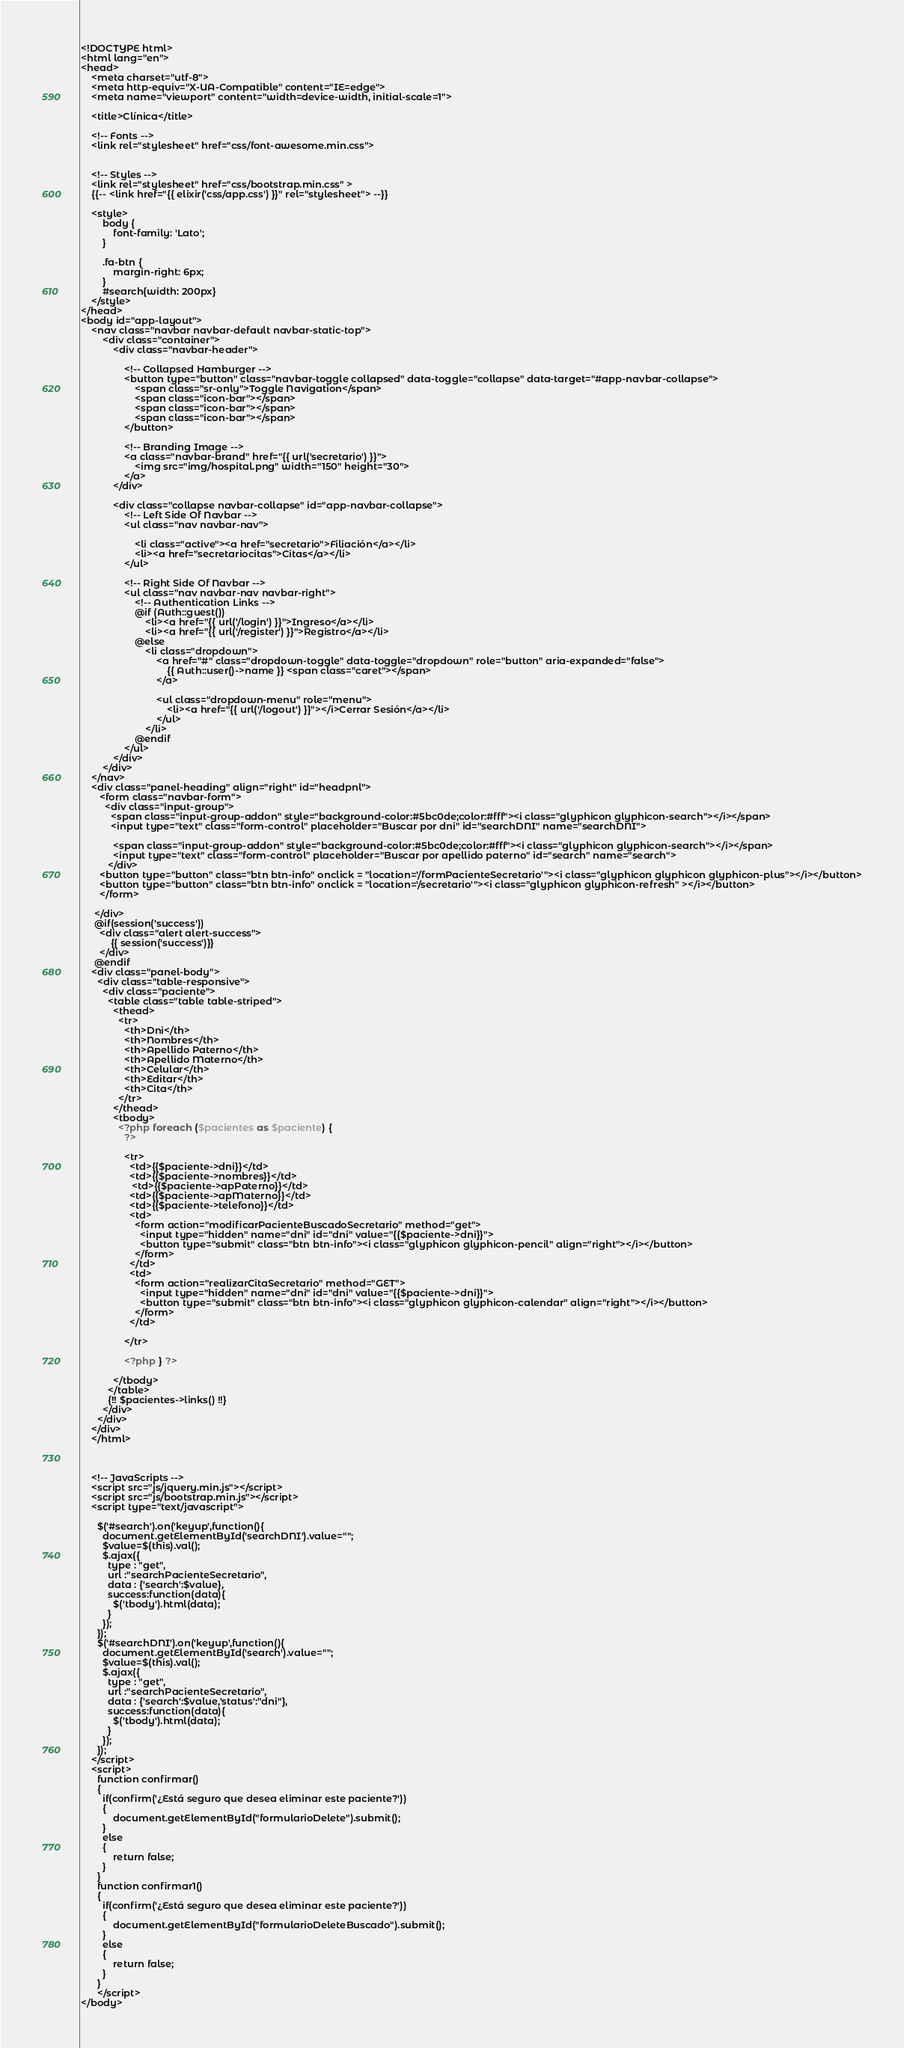<code> <loc_0><loc_0><loc_500><loc_500><_PHP_><!DOCTYPE html>
<html lang="en">
<head>
    <meta charset="utf-8">
    <meta http-equiv="X-UA-Compatible" content="IE=edge">
    <meta name="viewport" content="width=device-width, initial-scale=1">

    <title>Clínica</title>

    <!-- Fonts -->
    <link rel="stylesheet" href="css/font-awesome.min.css">


    <!-- Styles -->
    <link rel="stylesheet" href="css/bootstrap.min.css" >
    {{-- <link href="{{ elixir('css/app.css') }}" rel="stylesheet"> --}}

    <style>
        body {
            font-family: 'Lato';
        }

        .fa-btn {
            margin-right: 6px;
        }
        #search{width: 200px}
    </style>
</head>
<body id="app-layout">
    <nav class="navbar navbar-default navbar-static-top">
        <div class="container">
            <div class="navbar-header">

                <!-- Collapsed Hamburger -->
                <button type="button" class="navbar-toggle collapsed" data-toggle="collapse" data-target="#app-navbar-collapse">
                    <span class="sr-only">Toggle Navigation</span>
                    <span class="icon-bar"></span>
                    <span class="icon-bar"></span>
                    <span class="icon-bar"></span>
                </button>

                <!-- Branding Image -->
                <a class="navbar-brand" href="{{ url('secretario') }}">
                    <img src="img/hospital.png" width="150" height="30">
                </a>
            </div>

            <div class="collapse navbar-collapse" id="app-navbar-collapse">
                <!-- Left Side Of Navbar -->
                <ul class="nav navbar-nav">

                    <li class="active"><a href="secretario">Filiación</a></li>
                    <li><a href="secretariocitas">Citas</a></li>
                </ul>

                <!-- Right Side Of Navbar -->
                <ul class="nav navbar-nav navbar-right">
                    <!-- Authentication Links -->
                    @if (Auth::guest())
                        <li><a href="{{ url('/login') }}">Ingreso</a></li>
                        <li><a href="{{ url('/register') }}">Registro</a></li>
                    @else
                        <li class="dropdown">
                            <a href="#" class="dropdown-toggle" data-toggle="dropdown" role="button" aria-expanded="false">
                                {{ Auth::user()->name }} <span class="caret"></span>
                            </a>

                            <ul class="dropdown-menu" role="menu">
                                <li><a href="{{ url('/logout') }}"></i>Cerrar Sesión</a></li>
                            </ul>
                        </li>
                    @endif
                </ul>
            </div>
        </div>
    </nav>
    <div class="panel-heading" align="right" id="headpnl">
       <form class="navbar-form">
         <div class="input-group">
           <span class="input-group-addon" style="background-color:#5bc0de;color:#fff"><i class="glyphicon glyphicon-search"></i></span>
           <input type="text" class="form-control" placeholder="Buscar por dni" id="searchDNI" name="searchDNI">

            <span class="input-group-addon" style="background-color:#5bc0de;color:#fff"><i class="glyphicon glyphicon-search"></i></span>
            <input type="text" class="form-control" placeholder="Buscar por apellido paterno" id="search" name="search">
          </div>
       <button type="button" class="btn btn-info" onclick = "location='/formPacienteSecretario'"><i class="glyphicon glyphicon glyphicon-plus"></i></button>
       <button type="button" class="btn btn-info" onclick = "location='/secretario'"><i class="glyphicon glyphicon-refresh" ></i></button>
       </form>

     </div>
     @if(session('success'))
       <div class="alert alert-success">
           {{ session('success')}}
       </div>
     @endif
    <div class="panel-body">
      <div class="table-responsive">
        <div class="paciente">
          <table class="table table-striped">
            <thead>
              <tr>
                <th>Dni</th>
                <th>Nombres</th>
                <th>Apellido Paterno</th>
                <th>Apellido Materno</th>
                <th>Celular</th>
                <th>Editar</th>
                <th>Cita</th>
              </tr>
            </thead>
            <tbody>
              <?php foreach ($pacientes as $paciente) {
                ?>

                <tr>
                  <td>{{$paciente->dni}}</td>
                  <td>{{$paciente->nombres}}</td>
                   <td>{{$paciente->apPaterno}}</td>
                  <td>{{$paciente->apMaterno}}</td>
                  <td>{{$paciente->telefono}}</td>
                  <td>
                    <form action="modificarPacienteBuscadoSecretario" method="get">
                      <input type="hidden" name="dni" id="dni" value="{{$paciente->dni}}">
                      <button type="submit" class="btn btn-info"><i class="glyphicon glyphicon-pencil" align="right"></i></button>
                    </form>
                  </td>
                  <td>
                    <form action="realizarCitaSecretario" method="GET">
                      <input type="hidden" name="dni" id="dni" value="{{$paciente->dni}}">
                      <button type="submit" class="btn btn-info"><i class="glyphicon glyphicon-calendar" align="right"></i></button>
                    </form>
                  </td>

                </tr>

                <?php } ?>

            </tbody>
          </table>
          {!! $pacientes->links() !!}
        </div>
      </div>
    </div>
    </html>



    <!-- JavaScripts -->
    <script src="js/jquery.min.js"></script>
    <script src="js/bootstrap.min.js"></script>
    <script type="text/javascript">

      $('#search').on('keyup',function(){
        document.getElementById('searchDNI').value="";
        $value=$(this).val();
        $.ajax({
          type : "get",
          url :"searchPacienteSecretario",
          data : {'search':$value},
          success:function(data){
            $('tbody').html(data);
          }
        });
      });
      $('#searchDNI').on('keyup',function(){
        document.getElementById('search').value="";
        $value=$(this).val();
        $.ajax({
          type : "get",
          url :"searchPacienteSecretario",
          data : {'search':$value,'status':"dni"},
          success:function(data){
            $('tbody').html(data);
          }
        });
      });
    </script>
    <script>
      function confirmar()
      {
      	if(confirm('¿Está seguro que desea eliminar este paciente?'))
      	{
      		document.getElementById("formularioDelete").submit();
      	}
      	else
      	{
      		return false;
      	}
      }
      function confirmar1()
      {
      	if(confirm('¿Está seguro que desea eliminar este paciente?'))
      	{
      		document.getElementById("formularioDeleteBuscado").submit();
      	}
      	else
      	{
      		return false;
      	}
      }
      </script>
</body>
</code> 